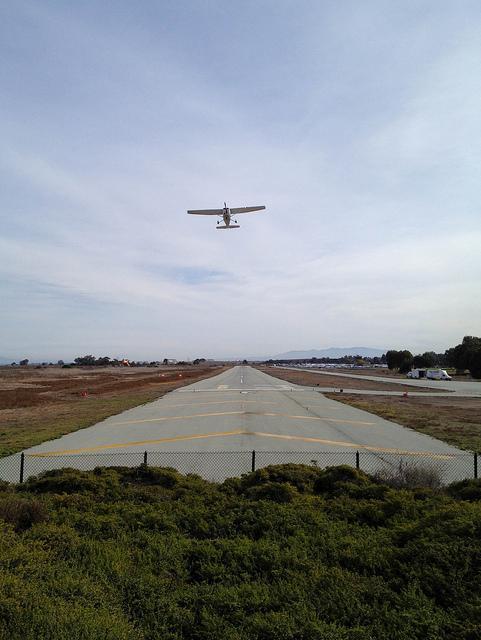How many lanes are on the road?
Give a very brief answer. 1. How many planes are there?
Give a very brief answer. 1. How many elephants are under a tree branch?
Give a very brief answer. 0. 